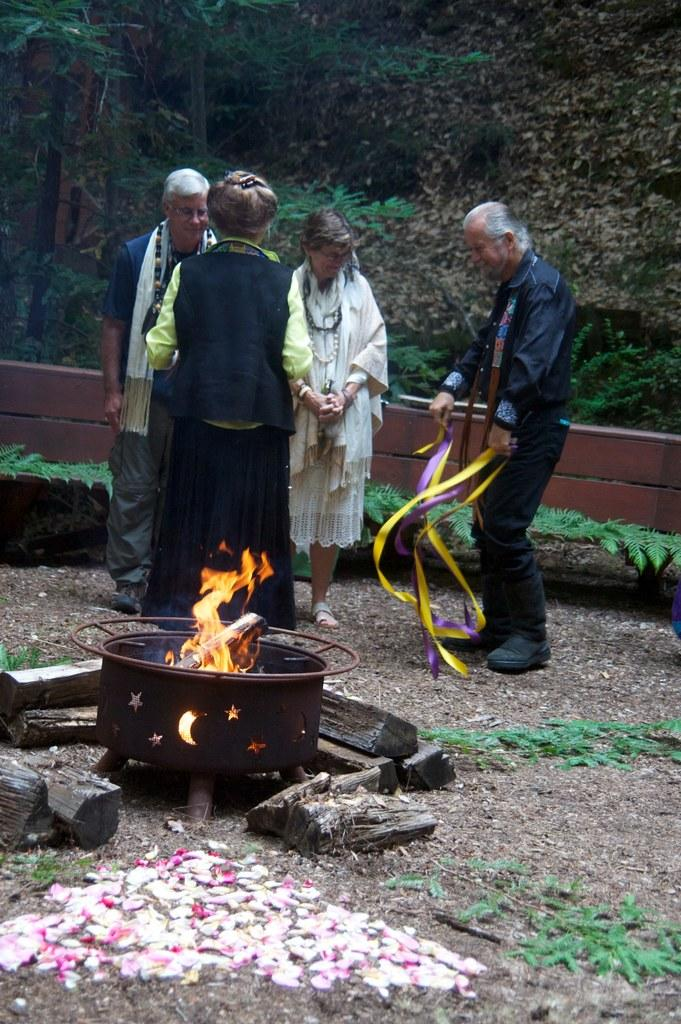How many people are present in the image? There are four people standing in the image. What are the people wearing? The people are wearing clothes. What can be seen in the image that is related to fire? There is a flame visible in the image. What type of sticks are present in the image? There are wooden sticks in the image. What is the container made of that is visible in the image? The container is made of metal. What type of natural environment is visible in the image? There is grass, a wooden fence, and trees visible in the image. What is the front of the place where the people are standing in the image? There is no specific place mentioned in the image, so it is not possible to determine the front of it. 